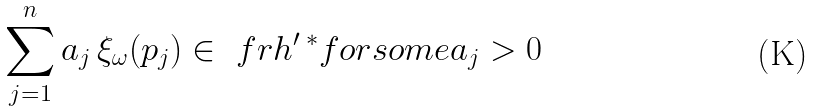<formula> <loc_0><loc_0><loc_500><loc_500>\sum _ { j = 1 } ^ { n } a _ { j } \, \xi _ { \omega } ( p _ { j } ) \in \ f r h ^ { \prime } \, ^ { * } f o r s o m e a _ { j } > 0</formula> 